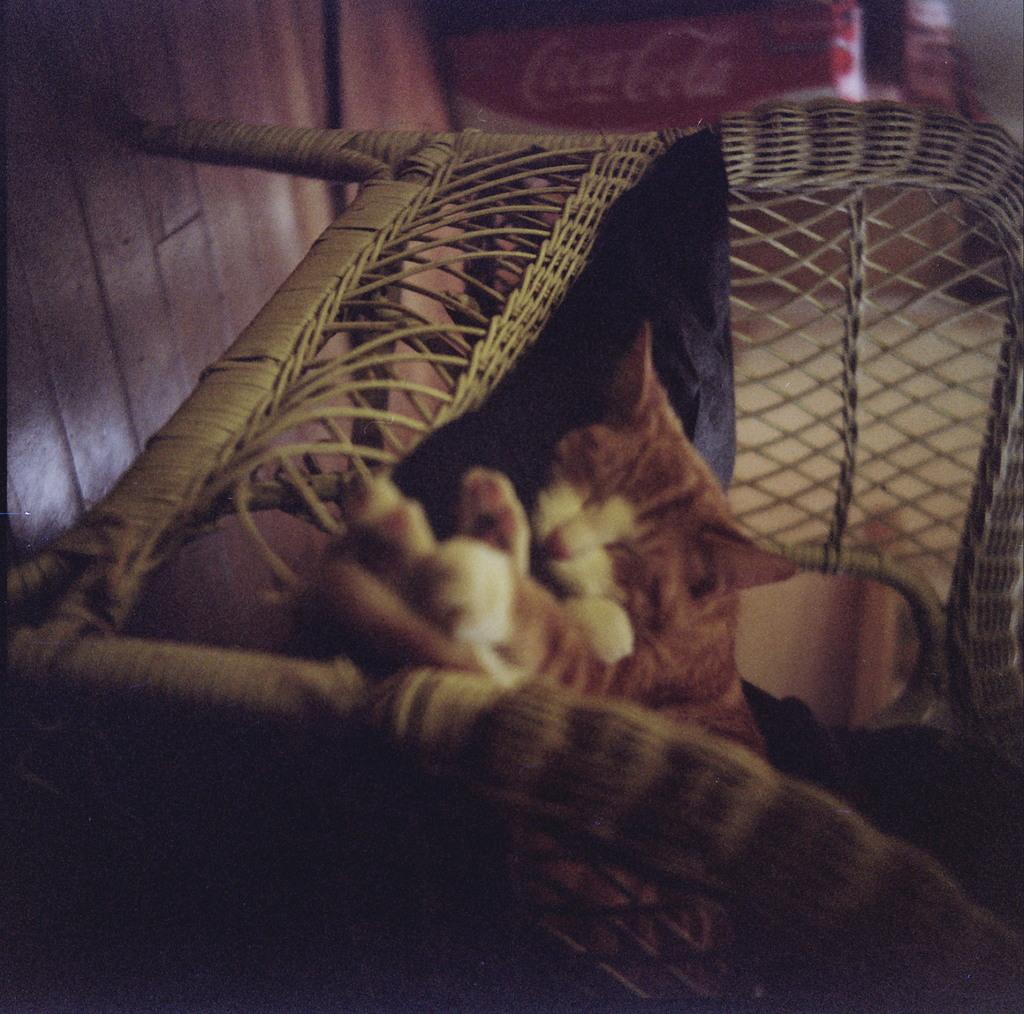What type of animal is present in the image? There is a cat in the image. What is the cat doing in the image? The cat is sleeping. Where is the cat located in the image? The cat is on a brown sofa chair. Can you tell me how many sheep are present in the image? There are no sheep present in the image; it features a cat sleeping on a brown sofa chair. 